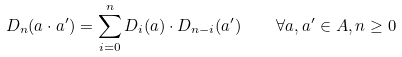Convert formula to latex. <formula><loc_0><loc_0><loc_500><loc_500>D _ { n } ( a \cdot a ^ { \prime } ) = \sum _ { i = 0 } ^ { n } D _ { i } ( a ) \cdot D _ { n - i } ( a ^ { \prime } ) \quad \forall a , a ^ { \prime } \in A , n \geq 0</formula> 